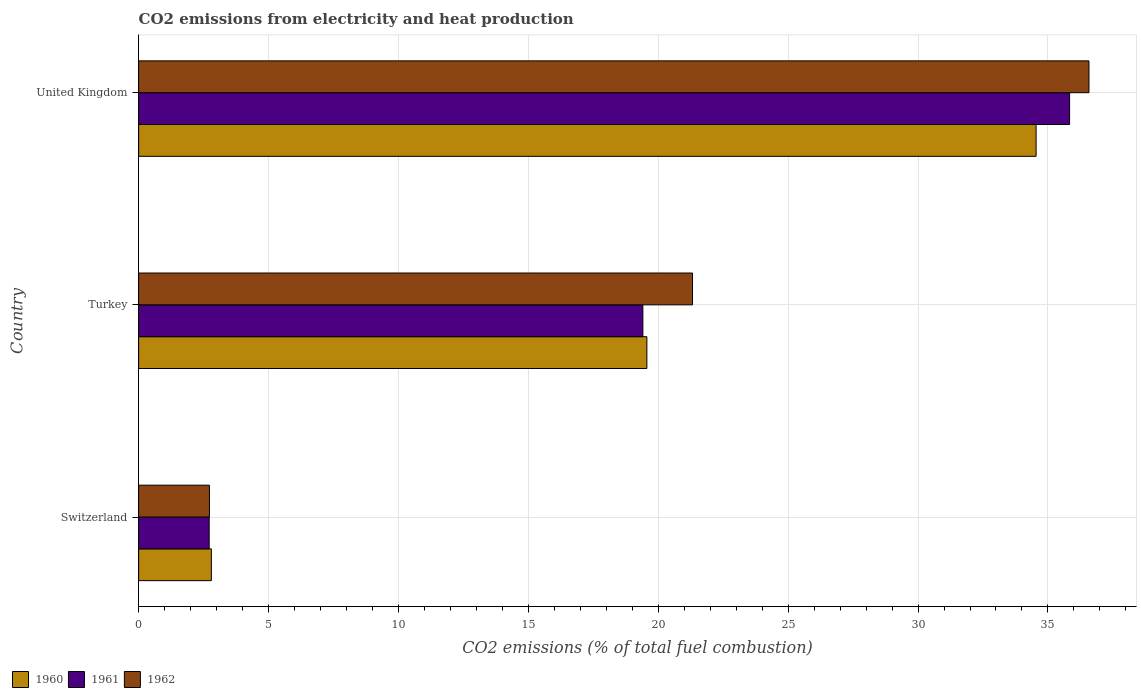Are the number of bars on each tick of the Y-axis equal?
Offer a terse response. Yes. How many bars are there on the 2nd tick from the top?
Your response must be concise. 3. What is the label of the 3rd group of bars from the top?
Provide a succinct answer. Switzerland. What is the amount of CO2 emitted in 1960 in Switzerland?
Offer a very short reply. 2.8. Across all countries, what is the maximum amount of CO2 emitted in 1961?
Give a very brief answer. 35.83. Across all countries, what is the minimum amount of CO2 emitted in 1961?
Your response must be concise. 2.72. In which country was the amount of CO2 emitted in 1960 maximum?
Offer a terse response. United Kingdom. In which country was the amount of CO2 emitted in 1960 minimum?
Provide a succinct answer. Switzerland. What is the total amount of CO2 emitted in 1961 in the graph?
Your answer should be very brief. 57.96. What is the difference between the amount of CO2 emitted in 1961 in Switzerland and that in United Kingdom?
Your answer should be compact. -33.12. What is the difference between the amount of CO2 emitted in 1962 in Turkey and the amount of CO2 emitted in 1961 in Switzerland?
Offer a terse response. 18.6. What is the average amount of CO2 emitted in 1961 per country?
Your response must be concise. 19.32. What is the difference between the amount of CO2 emitted in 1960 and amount of CO2 emitted in 1961 in United Kingdom?
Make the answer very short. -1.29. In how many countries, is the amount of CO2 emitted in 1960 greater than 23 %?
Provide a succinct answer. 1. What is the ratio of the amount of CO2 emitted in 1960 in Switzerland to that in United Kingdom?
Keep it short and to the point. 0.08. Is the amount of CO2 emitted in 1961 in Switzerland less than that in United Kingdom?
Offer a very short reply. Yes. What is the difference between the highest and the second highest amount of CO2 emitted in 1962?
Ensure brevity in your answer.  15.26. What is the difference between the highest and the lowest amount of CO2 emitted in 1961?
Your answer should be very brief. 33.12. Is the sum of the amount of CO2 emitted in 1960 in Switzerland and United Kingdom greater than the maximum amount of CO2 emitted in 1961 across all countries?
Provide a succinct answer. Yes. What does the 3rd bar from the top in Turkey represents?
Offer a terse response. 1960. What does the 3rd bar from the bottom in Turkey represents?
Your answer should be very brief. 1962. What is the difference between two consecutive major ticks on the X-axis?
Ensure brevity in your answer.  5. Are the values on the major ticks of X-axis written in scientific E-notation?
Your response must be concise. No. Does the graph contain any zero values?
Provide a short and direct response. No. Does the graph contain grids?
Offer a very short reply. Yes. Where does the legend appear in the graph?
Give a very brief answer. Bottom left. How many legend labels are there?
Ensure brevity in your answer.  3. How are the legend labels stacked?
Provide a succinct answer. Horizontal. What is the title of the graph?
Offer a terse response. CO2 emissions from electricity and heat production. What is the label or title of the X-axis?
Your answer should be compact. CO2 emissions (% of total fuel combustion). What is the CO2 emissions (% of total fuel combustion) of 1960 in Switzerland?
Offer a very short reply. 2.8. What is the CO2 emissions (% of total fuel combustion) of 1961 in Switzerland?
Provide a succinct answer. 2.72. What is the CO2 emissions (% of total fuel combustion) in 1962 in Switzerland?
Provide a succinct answer. 2.72. What is the CO2 emissions (% of total fuel combustion) in 1960 in Turkey?
Ensure brevity in your answer.  19.56. What is the CO2 emissions (% of total fuel combustion) of 1961 in Turkey?
Make the answer very short. 19.41. What is the CO2 emissions (% of total fuel combustion) of 1962 in Turkey?
Keep it short and to the point. 21.32. What is the CO2 emissions (% of total fuel combustion) in 1960 in United Kingdom?
Provide a short and direct response. 34.54. What is the CO2 emissions (% of total fuel combustion) of 1961 in United Kingdom?
Offer a terse response. 35.83. What is the CO2 emissions (% of total fuel combustion) in 1962 in United Kingdom?
Keep it short and to the point. 36.58. Across all countries, what is the maximum CO2 emissions (% of total fuel combustion) in 1960?
Your answer should be very brief. 34.54. Across all countries, what is the maximum CO2 emissions (% of total fuel combustion) of 1961?
Give a very brief answer. 35.83. Across all countries, what is the maximum CO2 emissions (% of total fuel combustion) in 1962?
Your answer should be very brief. 36.58. Across all countries, what is the minimum CO2 emissions (% of total fuel combustion) in 1960?
Your answer should be very brief. 2.8. Across all countries, what is the minimum CO2 emissions (% of total fuel combustion) in 1961?
Give a very brief answer. 2.72. Across all countries, what is the minimum CO2 emissions (% of total fuel combustion) of 1962?
Make the answer very short. 2.72. What is the total CO2 emissions (% of total fuel combustion) of 1960 in the graph?
Ensure brevity in your answer.  56.91. What is the total CO2 emissions (% of total fuel combustion) in 1961 in the graph?
Offer a terse response. 57.96. What is the total CO2 emissions (% of total fuel combustion) in 1962 in the graph?
Offer a very short reply. 60.62. What is the difference between the CO2 emissions (% of total fuel combustion) of 1960 in Switzerland and that in Turkey?
Your answer should be compact. -16.76. What is the difference between the CO2 emissions (% of total fuel combustion) in 1961 in Switzerland and that in Turkey?
Ensure brevity in your answer.  -16.69. What is the difference between the CO2 emissions (% of total fuel combustion) in 1962 in Switzerland and that in Turkey?
Provide a succinct answer. -18.59. What is the difference between the CO2 emissions (% of total fuel combustion) of 1960 in Switzerland and that in United Kingdom?
Make the answer very short. -31.74. What is the difference between the CO2 emissions (% of total fuel combustion) in 1961 in Switzerland and that in United Kingdom?
Offer a terse response. -33.12. What is the difference between the CO2 emissions (% of total fuel combustion) of 1962 in Switzerland and that in United Kingdom?
Offer a terse response. -33.85. What is the difference between the CO2 emissions (% of total fuel combustion) in 1960 in Turkey and that in United Kingdom?
Your answer should be very brief. -14.98. What is the difference between the CO2 emissions (% of total fuel combustion) of 1961 in Turkey and that in United Kingdom?
Give a very brief answer. -16.42. What is the difference between the CO2 emissions (% of total fuel combustion) in 1962 in Turkey and that in United Kingdom?
Offer a very short reply. -15.26. What is the difference between the CO2 emissions (% of total fuel combustion) in 1960 in Switzerland and the CO2 emissions (% of total fuel combustion) in 1961 in Turkey?
Keep it short and to the point. -16.61. What is the difference between the CO2 emissions (% of total fuel combustion) of 1960 in Switzerland and the CO2 emissions (% of total fuel combustion) of 1962 in Turkey?
Make the answer very short. -18.52. What is the difference between the CO2 emissions (% of total fuel combustion) in 1961 in Switzerland and the CO2 emissions (% of total fuel combustion) in 1962 in Turkey?
Give a very brief answer. -18.6. What is the difference between the CO2 emissions (% of total fuel combustion) of 1960 in Switzerland and the CO2 emissions (% of total fuel combustion) of 1961 in United Kingdom?
Your answer should be compact. -33.03. What is the difference between the CO2 emissions (% of total fuel combustion) of 1960 in Switzerland and the CO2 emissions (% of total fuel combustion) of 1962 in United Kingdom?
Keep it short and to the point. -33.78. What is the difference between the CO2 emissions (% of total fuel combustion) of 1961 in Switzerland and the CO2 emissions (% of total fuel combustion) of 1962 in United Kingdom?
Ensure brevity in your answer.  -33.86. What is the difference between the CO2 emissions (% of total fuel combustion) in 1960 in Turkey and the CO2 emissions (% of total fuel combustion) in 1961 in United Kingdom?
Make the answer very short. -16.27. What is the difference between the CO2 emissions (% of total fuel combustion) in 1960 in Turkey and the CO2 emissions (% of total fuel combustion) in 1962 in United Kingdom?
Your response must be concise. -17.02. What is the difference between the CO2 emissions (% of total fuel combustion) of 1961 in Turkey and the CO2 emissions (% of total fuel combustion) of 1962 in United Kingdom?
Offer a terse response. -17.17. What is the average CO2 emissions (% of total fuel combustion) in 1960 per country?
Offer a very short reply. 18.97. What is the average CO2 emissions (% of total fuel combustion) of 1961 per country?
Offer a very short reply. 19.32. What is the average CO2 emissions (% of total fuel combustion) in 1962 per country?
Your response must be concise. 20.21. What is the difference between the CO2 emissions (% of total fuel combustion) of 1960 and CO2 emissions (% of total fuel combustion) of 1961 in Switzerland?
Ensure brevity in your answer.  0.08. What is the difference between the CO2 emissions (% of total fuel combustion) of 1960 and CO2 emissions (% of total fuel combustion) of 1962 in Switzerland?
Offer a very short reply. 0.07. What is the difference between the CO2 emissions (% of total fuel combustion) of 1961 and CO2 emissions (% of total fuel combustion) of 1962 in Switzerland?
Provide a short and direct response. -0.01. What is the difference between the CO2 emissions (% of total fuel combustion) in 1960 and CO2 emissions (% of total fuel combustion) in 1961 in Turkey?
Ensure brevity in your answer.  0.15. What is the difference between the CO2 emissions (% of total fuel combustion) in 1960 and CO2 emissions (% of total fuel combustion) in 1962 in Turkey?
Your response must be concise. -1.76. What is the difference between the CO2 emissions (% of total fuel combustion) of 1961 and CO2 emissions (% of total fuel combustion) of 1962 in Turkey?
Your answer should be compact. -1.91. What is the difference between the CO2 emissions (% of total fuel combustion) in 1960 and CO2 emissions (% of total fuel combustion) in 1961 in United Kingdom?
Your response must be concise. -1.29. What is the difference between the CO2 emissions (% of total fuel combustion) of 1960 and CO2 emissions (% of total fuel combustion) of 1962 in United Kingdom?
Give a very brief answer. -2.03. What is the difference between the CO2 emissions (% of total fuel combustion) of 1961 and CO2 emissions (% of total fuel combustion) of 1962 in United Kingdom?
Keep it short and to the point. -0.75. What is the ratio of the CO2 emissions (% of total fuel combustion) in 1960 in Switzerland to that in Turkey?
Keep it short and to the point. 0.14. What is the ratio of the CO2 emissions (% of total fuel combustion) of 1961 in Switzerland to that in Turkey?
Make the answer very short. 0.14. What is the ratio of the CO2 emissions (% of total fuel combustion) in 1962 in Switzerland to that in Turkey?
Offer a terse response. 0.13. What is the ratio of the CO2 emissions (% of total fuel combustion) in 1960 in Switzerland to that in United Kingdom?
Offer a terse response. 0.08. What is the ratio of the CO2 emissions (% of total fuel combustion) in 1961 in Switzerland to that in United Kingdom?
Provide a succinct answer. 0.08. What is the ratio of the CO2 emissions (% of total fuel combustion) in 1962 in Switzerland to that in United Kingdom?
Your answer should be compact. 0.07. What is the ratio of the CO2 emissions (% of total fuel combustion) of 1960 in Turkey to that in United Kingdom?
Give a very brief answer. 0.57. What is the ratio of the CO2 emissions (% of total fuel combustion) of 1961 in Turkey to that in United Kingdom?
Your response must be concise. 0.54. What is the ratio of the CO2 emissions (% of total fuel combustion) in 1962 in Turkey to that in United Kingdom?
Your answer should be compact. 0.58. What is the difference between the highest and the second highest CO2 emissions (% of total fuel combustion) in 1960?
Keep it short and to the point. 14.98. What is the difference between the highest and the second highest CO2 emissions (% of total fuel combustion) in 1961?
Your response must be concise. 16.42. What is the difference between the highest and the second highest CO2 emissions (% of total fuel combustion) of 1962?
Your answer should be very brief. 15.26. What is the difference between the highest and the lowest CO2 emissions (% of total fuel combustion) of 1960?
Your answer should be very brief. 31.74. What is the difference between the highest and the lowest CO2 emissions (% of total fuel combustion) in 1961?
Keep it short and to the point. 33.12. What is the difference between the highest and the lowest CO2 emissions (% of total fuel combustion) in 1962?
Keep it short and to the point. 33.85. 